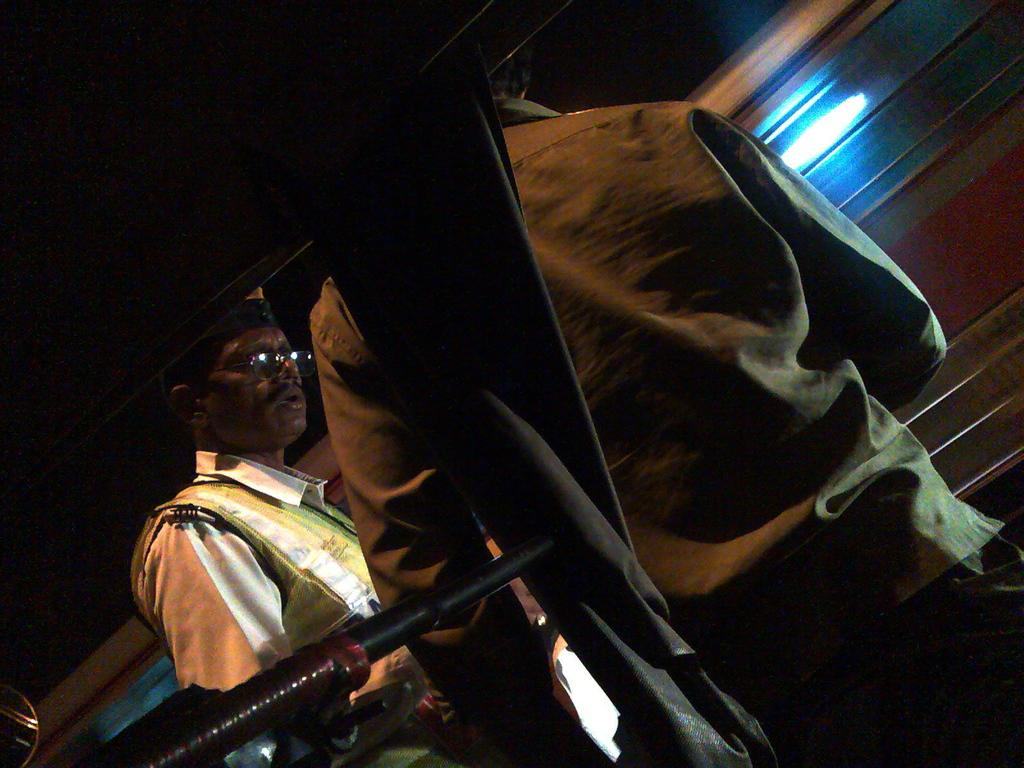How many people are present in the image? There are two people in the image. What is visible in the background of the image? There is a wall in the image. Can you describe the lighting conditions in the image? There is light in the image. What type of teeth can be seen in the image? There are no teeth visible in the image, as it features two people and teeth are not a part of the image. Can you tell me where the seashore is located in the image? There is no seashore present in the image. How old is the baby in the image? There is no baby present in the image. 